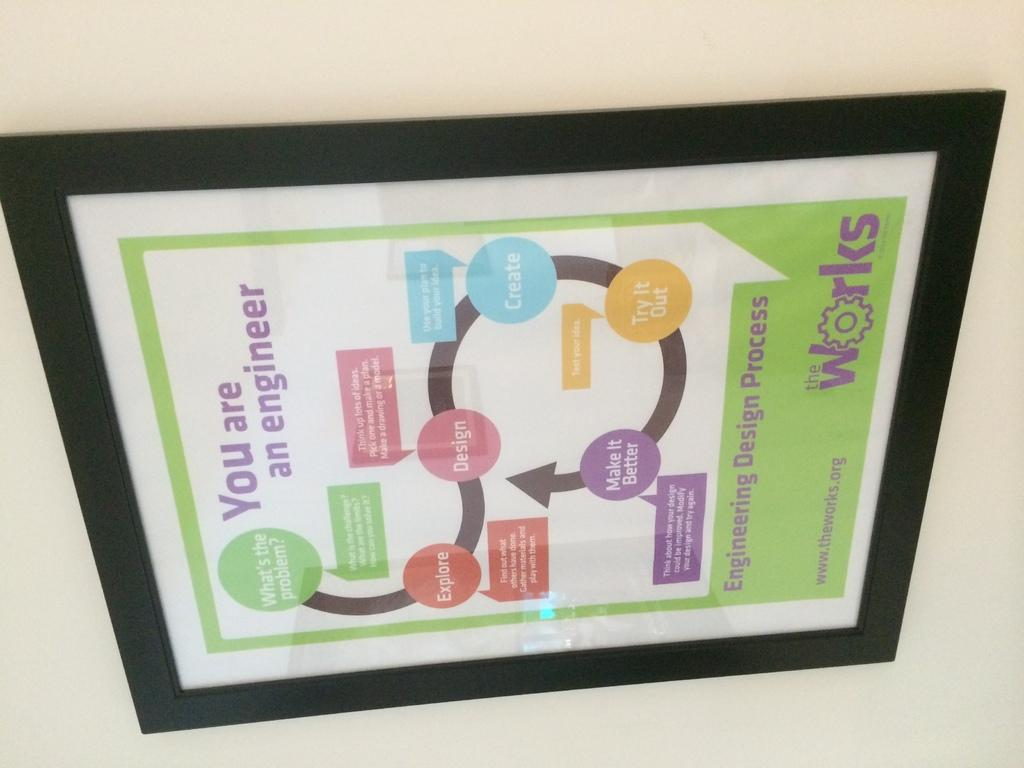<image>
Describe the image concisely. A poster depicting the "Engineering Design Process" by The Works, is in a black frame. 